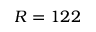Convert formula to latex. <formula><loc_0><loc_0><loc_500><loc_500>R = 1 2 2</formula> 